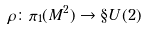Convert formula to latex. <formula><loc_0><loc_0><loc_500><loc_500>\rho \colon \pi _ { 1 } ( M ^ { 2 } ) \to \S U ( 2 )</formula> 